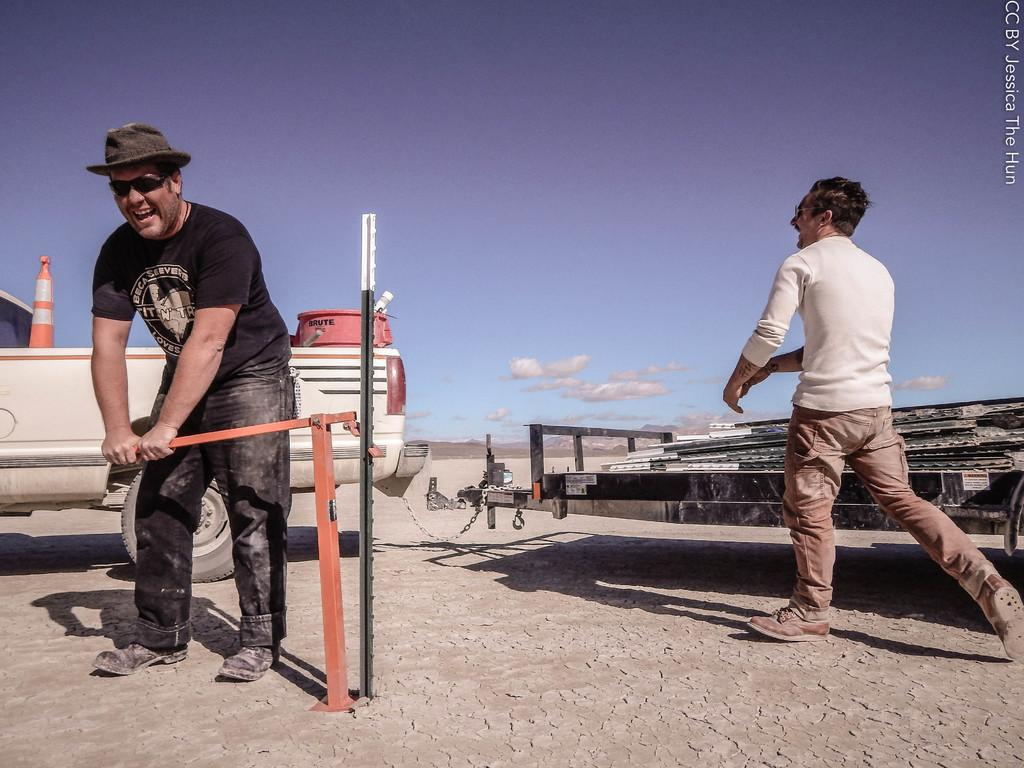What are the people in the image doing? The people in the image are on the floor. What can be seen attached with chains in the image? Vehicles are attached with chains in the image. What is one person holding in the image? One person is holding an object in the image. Can you tell me how many donkeys are present in the image? There are no donkeys present in the image. What type of health issues are the people in the image experiencing? The provided facts do not mention any health issues experienced by the people in the image. 